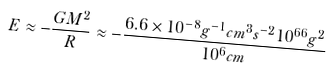<formula> <loc_0><loc_0><loc_500><loc_500>E \approx - \frac { G M ^ { 2 } } { R } \approx - \frac { 6 . 6 \times 1 0 ^ { - 8 } g ^ { - 1 } c m ^ { 3 } s ^ { - 2 } 1 0 ^ { 6 6 } g ^ { 2 } } { 1 0 ^ { 6 } c m }</formula> 